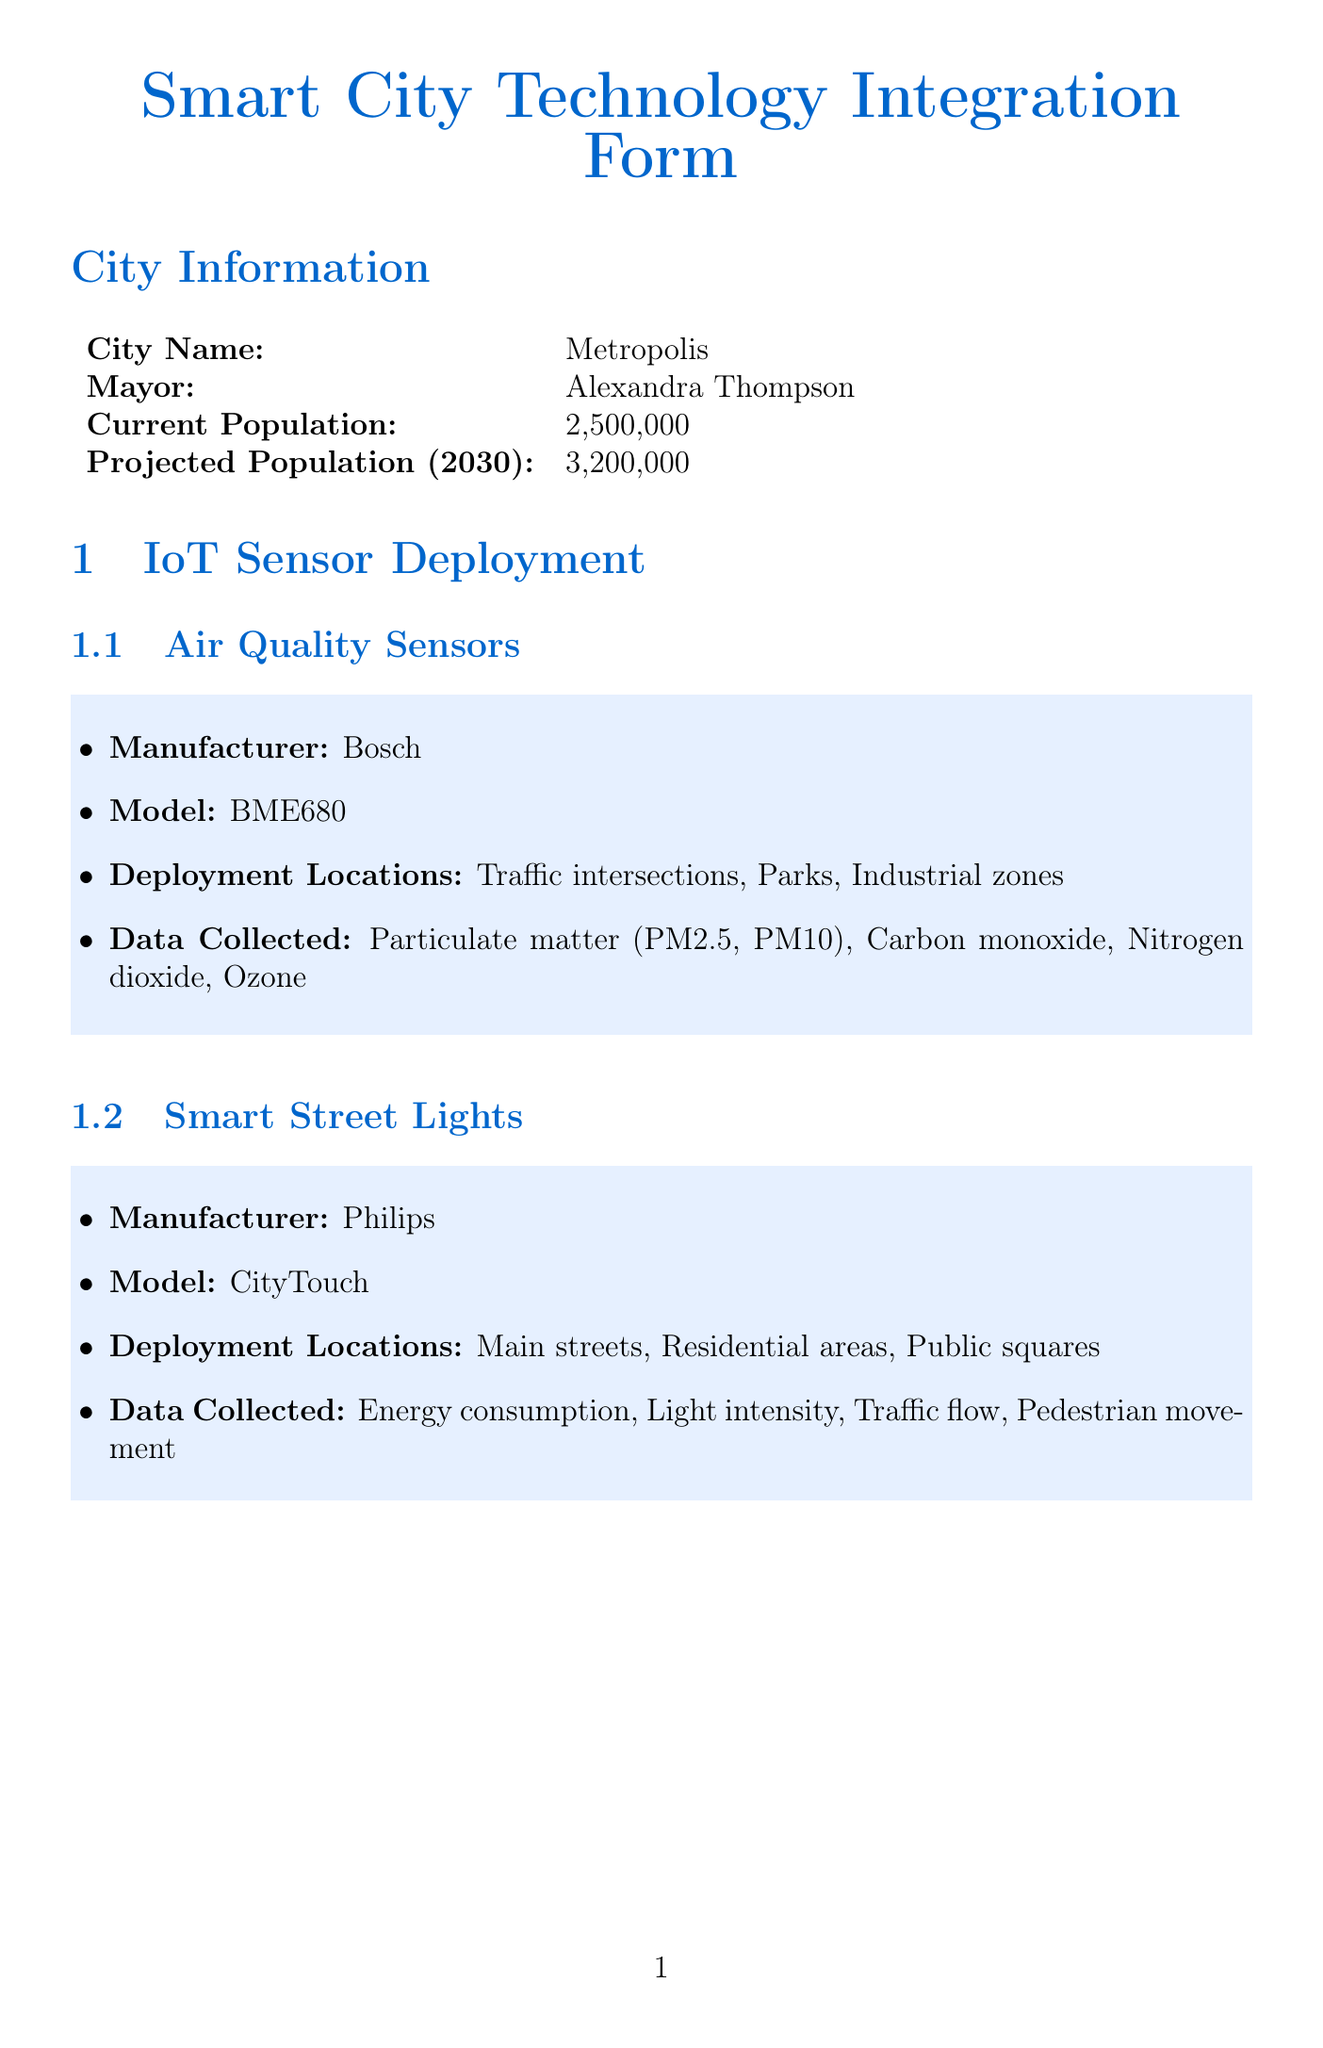What is the current population of Metropolis? The current population is stated in the document as 2,500,000.
Answer: 2,500,000 Which company provides Smart Grid Integration? The provider of Smart Grid Integration is mentioned in the Energy Management Systems section.
Answer: Siemens What frequency does the LoRaWAN Network transmit data? The data transmission frequency for LoRaWAN is specified in the Data Collection Methods section.
Answer: Every 15 minutes How many phases are in the implementation timeline? The number of phases can be counted from the Implementation Timeline section.
Answer: 3 What is the expected reduction in overall energy consumption? The expected outcomes provide a specific percentage related to energy consumption.
Answer: 20% Which locations are designated for Smart Street Lights deployment? The deployment locations for Smart Street Lights are listed in the IoT Sensor Deployment section.
Answer: Main streets, Residential areas, Public squares What type of sensor monitors water quality? The type of sensor focusing on water quality is found in the IoT Sensor Deployment section.
Answer: Water Quality Monitors What is the expected improvement in air quality indices? This information is mentioned in the Expected Outcomes section of the document.
Answer: 15% 